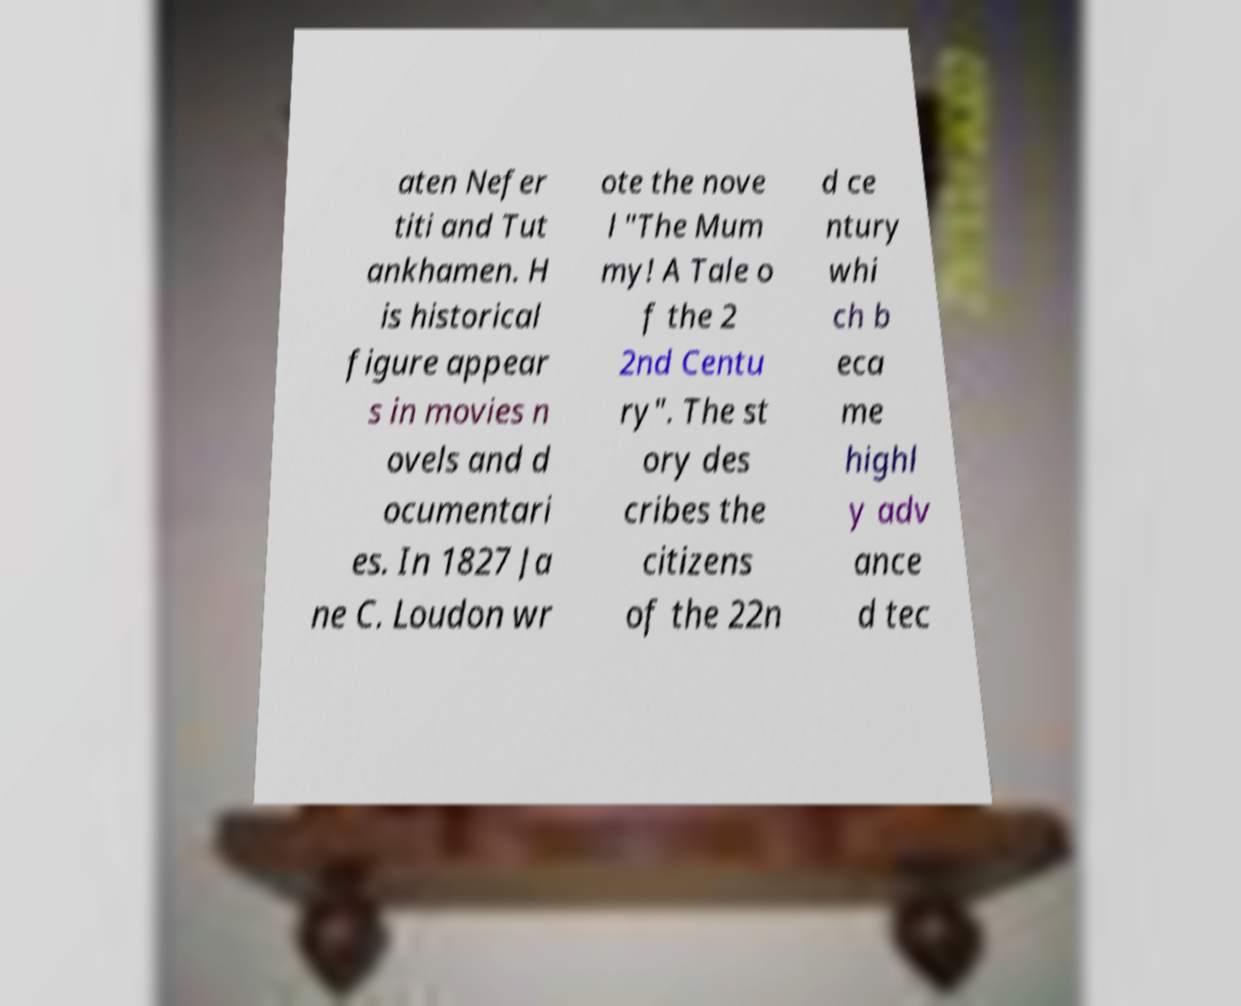Can you read and provide the text displayed in the image?This photo seems to have some interesting text. Can you extract and type it out for me? aten Nefer titi and Tut ankhamen. H is historical figure appear s in movies n ovels and d ocumentari es. In 1827 Ja ne C. Loudon wr ote the nove l "The Mum my! A Tale o f the 2 2nd Centu ry". The st ory des cribes the citizens of the 22n d ce ntury whi ch b eca me highl y adv ance d tec 